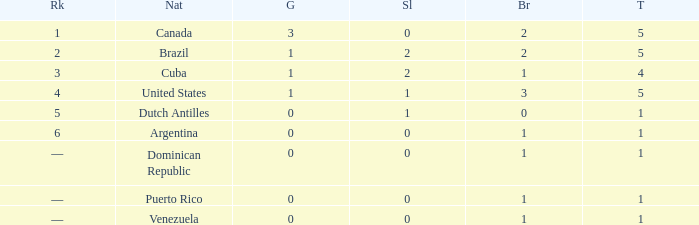What is the average gold total for nations ranked 6 with 1 total medal and 1 bronze medal? None. 